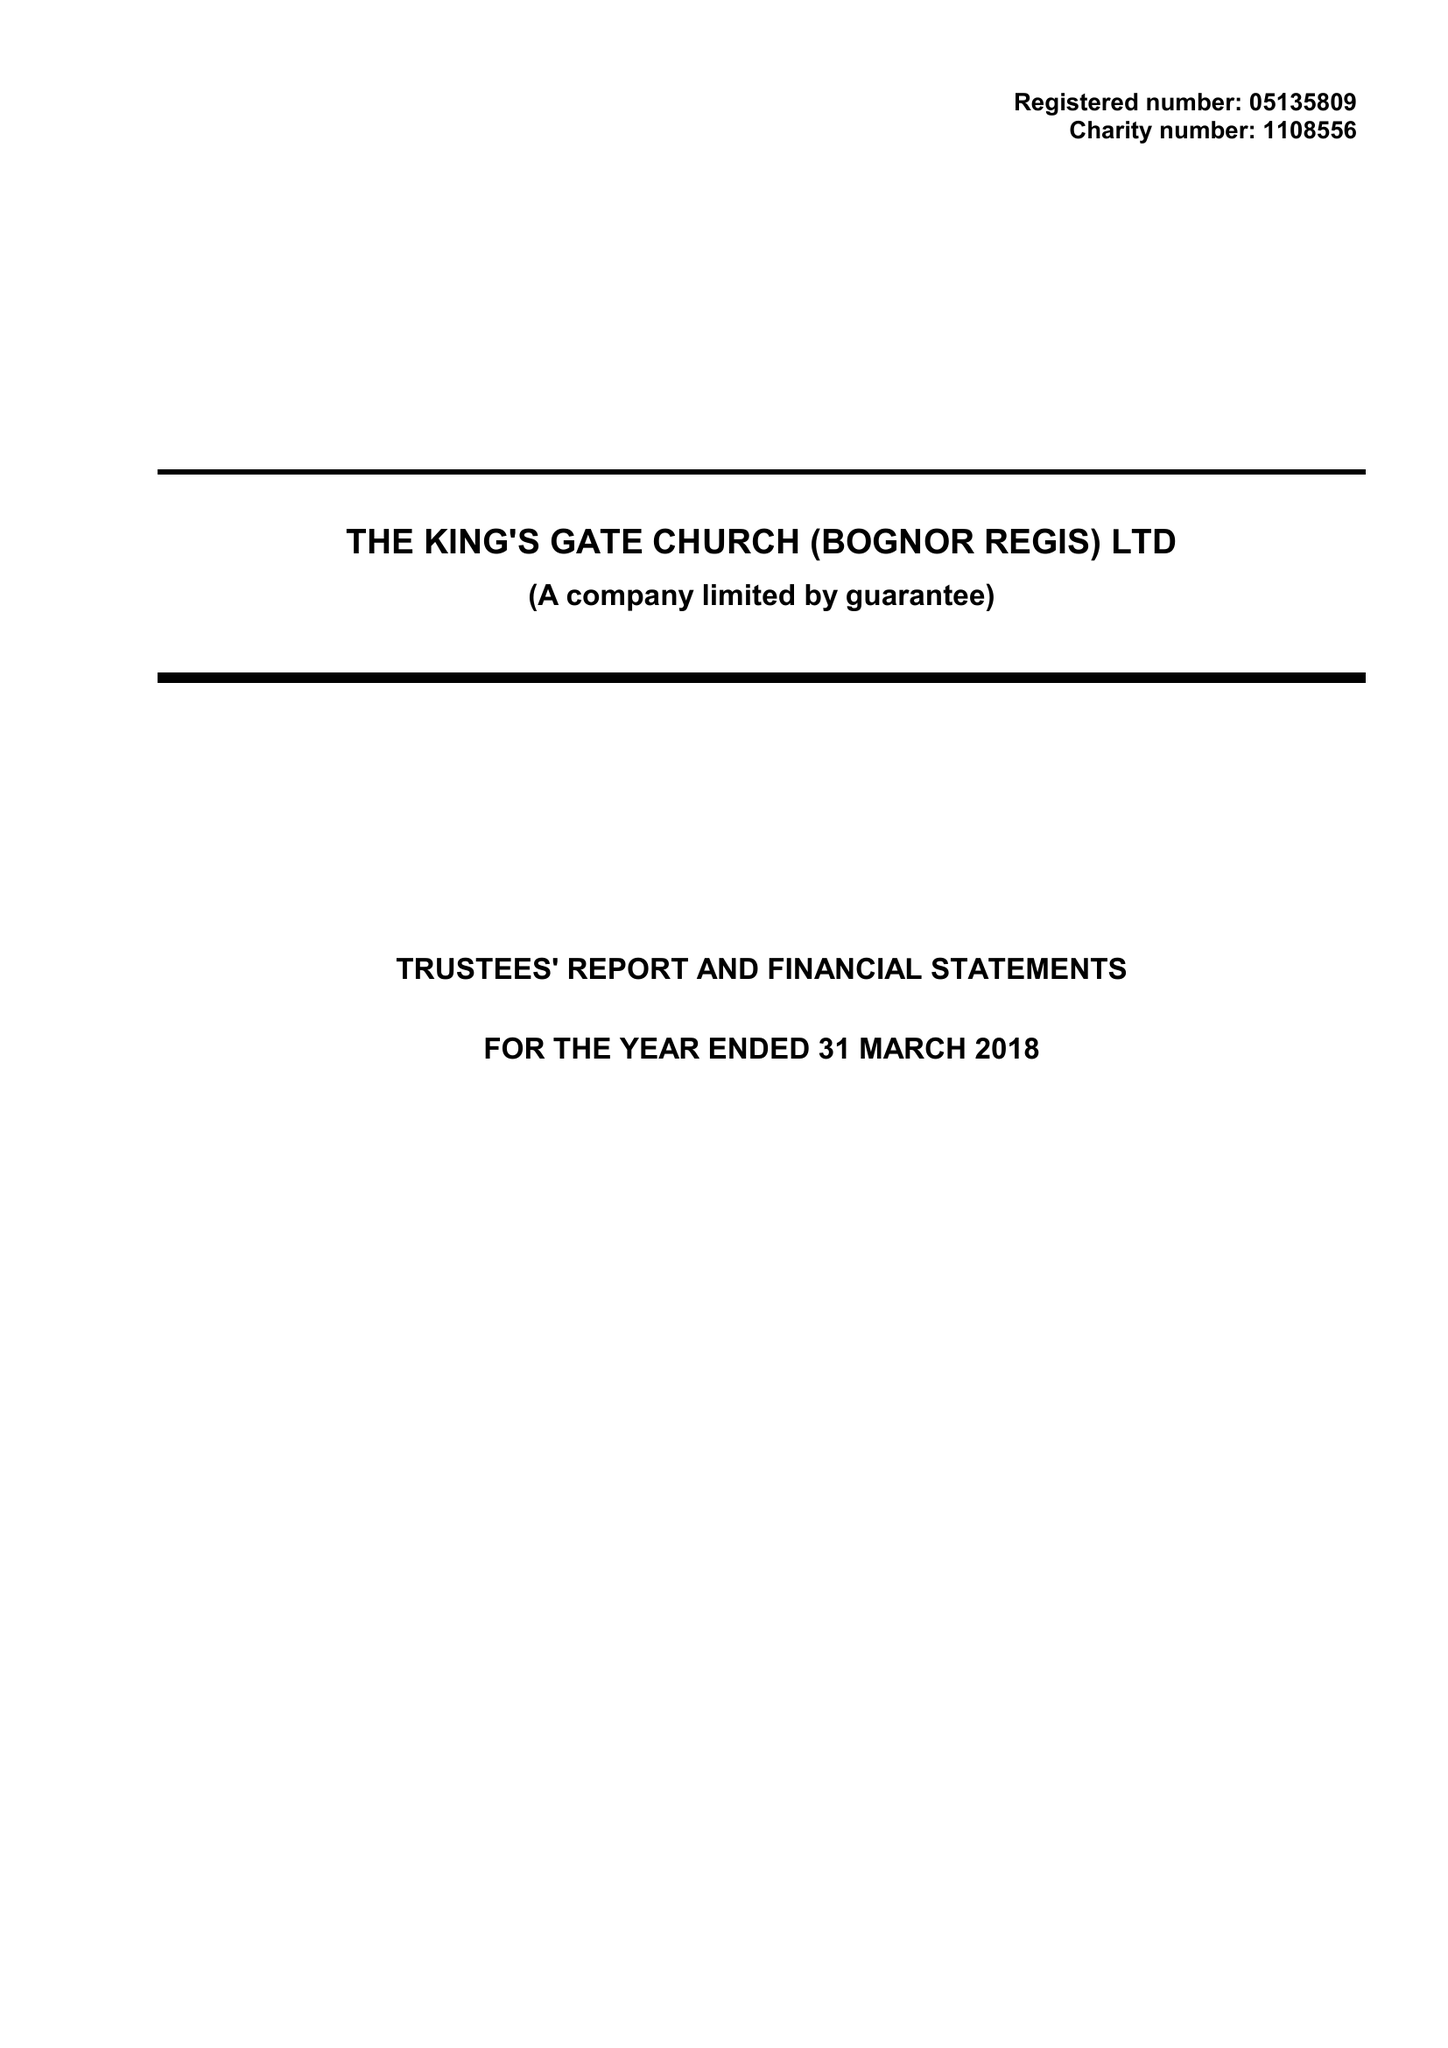What is the value for the report_date?
Answer the question using a single word or phrase. 2018-03-31 